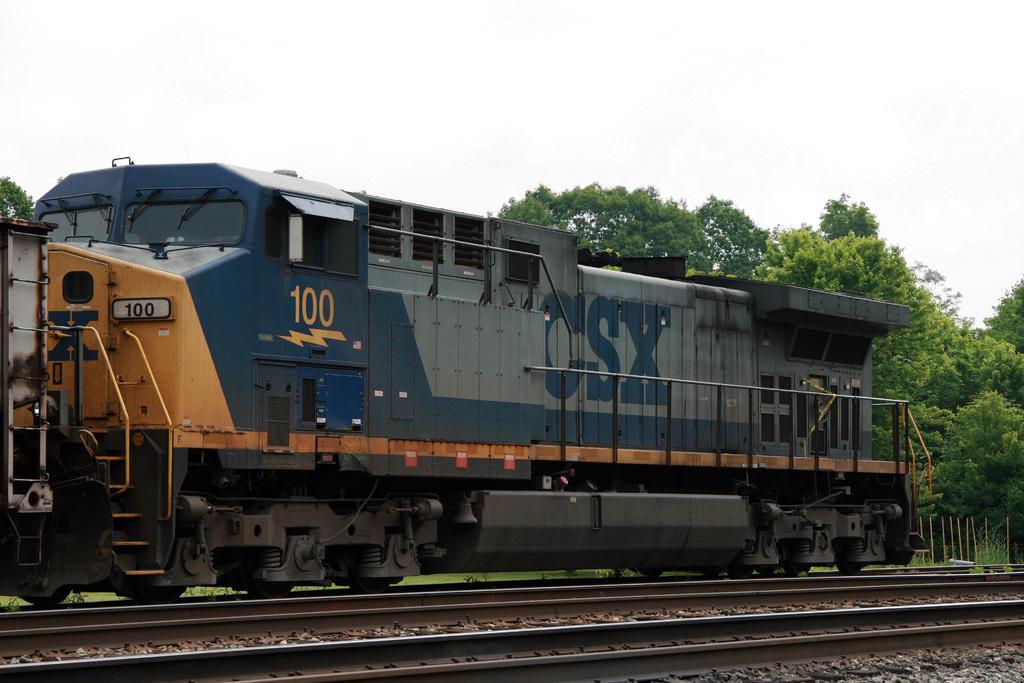Can you describe this image briefly? In this image we can see a train, railway track, trees, fence, also we can see the sky. 